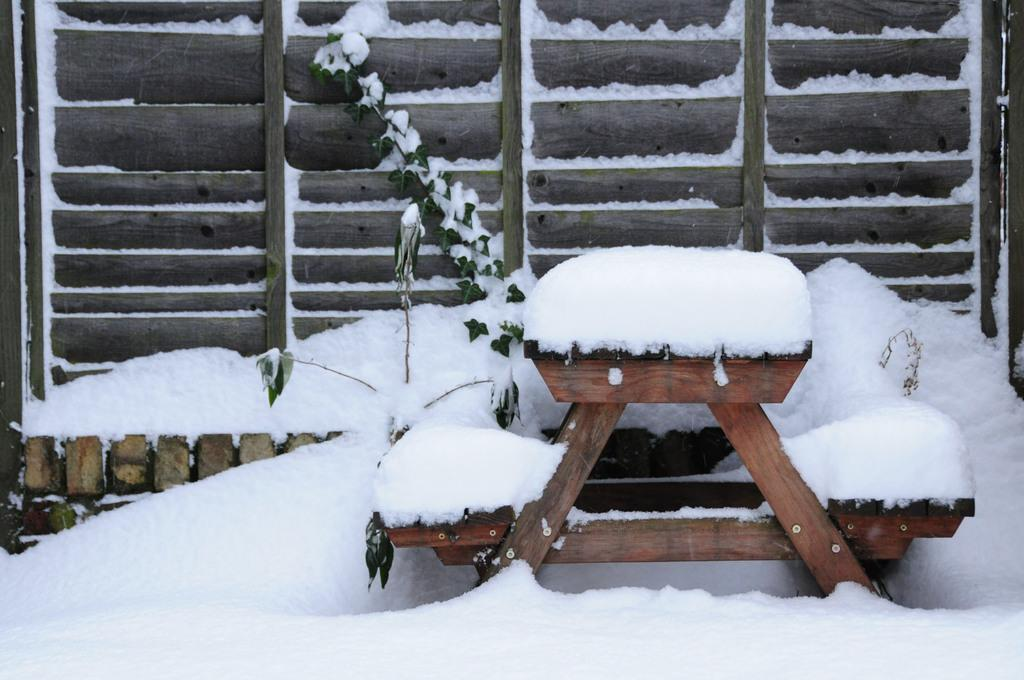What is the main object in the center of the image? There is a wooden table in the center of the image. What type of weather condition is depicted at the bottom of the image? There is snow at the bottom of the image. What can be seen in the background of the image? There is a gate in the background of the image. How many hands are visible in the image? There are no hands visible in the image. What type of plant is present at the bottom of the image? There is no plant present in the image; it depicts snow at the bottom. 